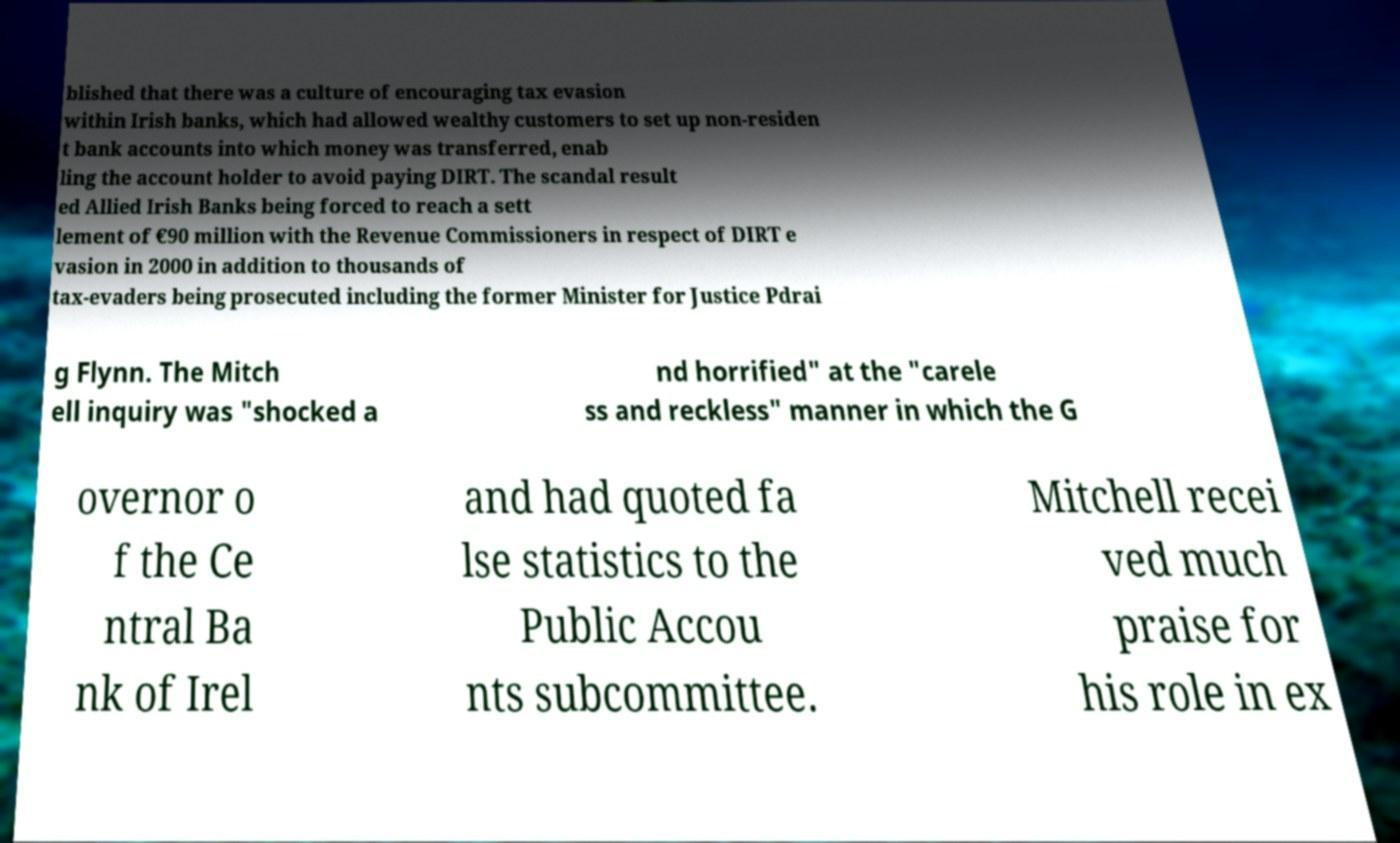Please read and relay the text visible in this image. What does it say? blished that there was a culture of encouraging tax evasion within Irish banks, which had allowed wealthy customers to set up non-residen t bank accounts into which money was transferred, enab ling the account holder to avoid paying DIRT. The scandal result ed Allied Irish Banks being forced to reach a sett lement of €90 million with the Revenue Commissioners in respect of DIRT e vasion in 2000 in addition to thousands of tax-evaders being prosecuted including the former Minister for Justice Pdrai g Flynn. The Mitch ell inquiry was "shocked a nd horrified" at the "carele ss and reckless" manner in which the G overnor o f the Ce ntral Ba nk of Irel and had quoted fa lse statistics to the Public Accou nts subcommittee. Mitchell recei ved much praise for his role in ex 